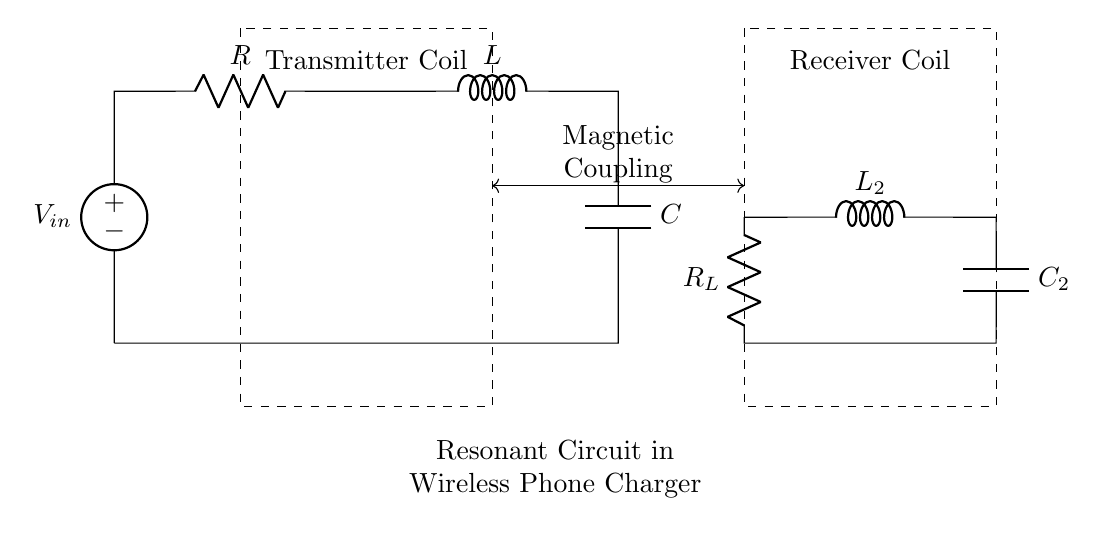What is the main function of the resistor in this circuit? The resistor limits the current flow within the circuit, providing stability and protection for the components.
Answer: Current limit What type of components are connected in this circuit? The circuit consists of a resistor, an inductor, and a capacitor, which together form a resonant circuit.
Answer: Resistor, inductor, capacitor What is the purpose of the magnetic coupling depicted in the diagram? Magnetic coupling transfers energy between the transmitter and receiver coils, enabling wireless power transfer.
Answer: Energy transfer Which component is responsible for storing energy in the magnetic field? The inductor is responsible for storing energy in the form of a magnetic field when current flows through it.
Answer: Inductor How do the inductor and capacitor interact in this resonant circuit? The inductor and capacitor work together to achieve resonance, which maximizes energy transfer at a specific frequency.
Answer: Achieve resonance What does the dashed rectangle surrounding the transmitter coil represent? The dashed rectangle represents the transmitter coil's physical boundary or housing, emphasizing its role in the wireless power system.
Answer: Transmitter coil boundary 